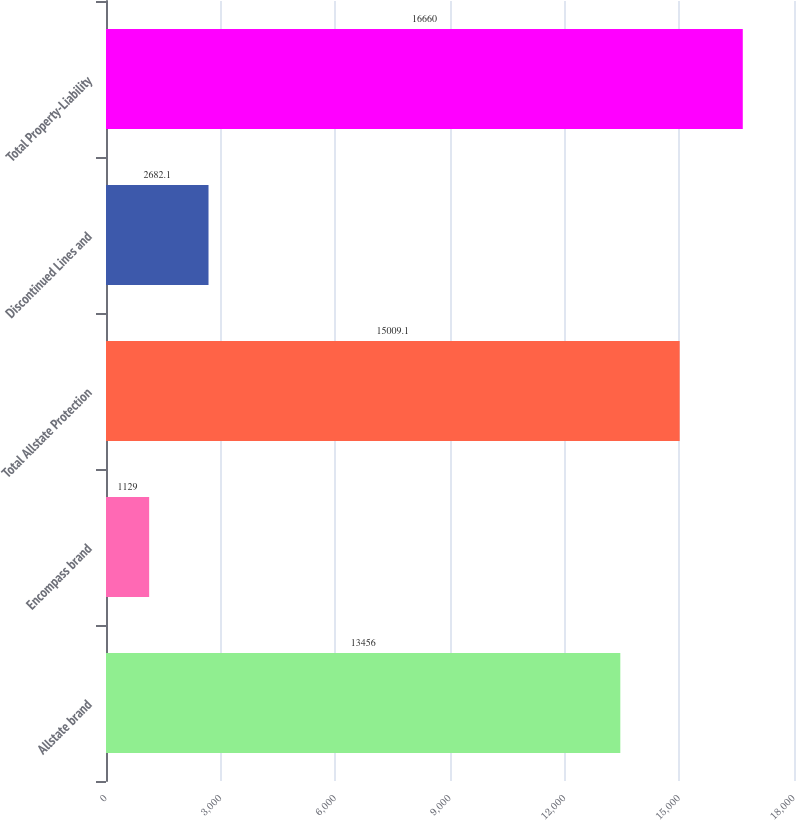Convert chart to OTSL. <chart><loc_0><loc_0><loc_500><loc_500><bar_chart><fcel>Allstate brand<fcel>Encompass brand<fcel>Total Allstate Protection<fcel>Discontinued Lines and<fcel>Total Property-Liability<nl><fcel>13456<fcel>1129<fcel>15009.1<fcel>2682.1<fcel>16660<nl></chart> 